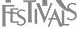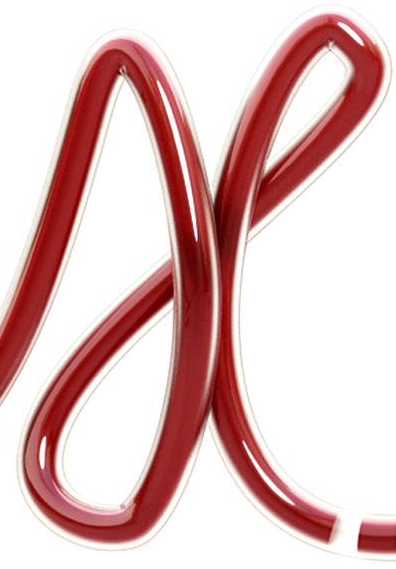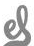Read the text from these images in sequence, separated by a semicolon. FESTIVALS; X; el 